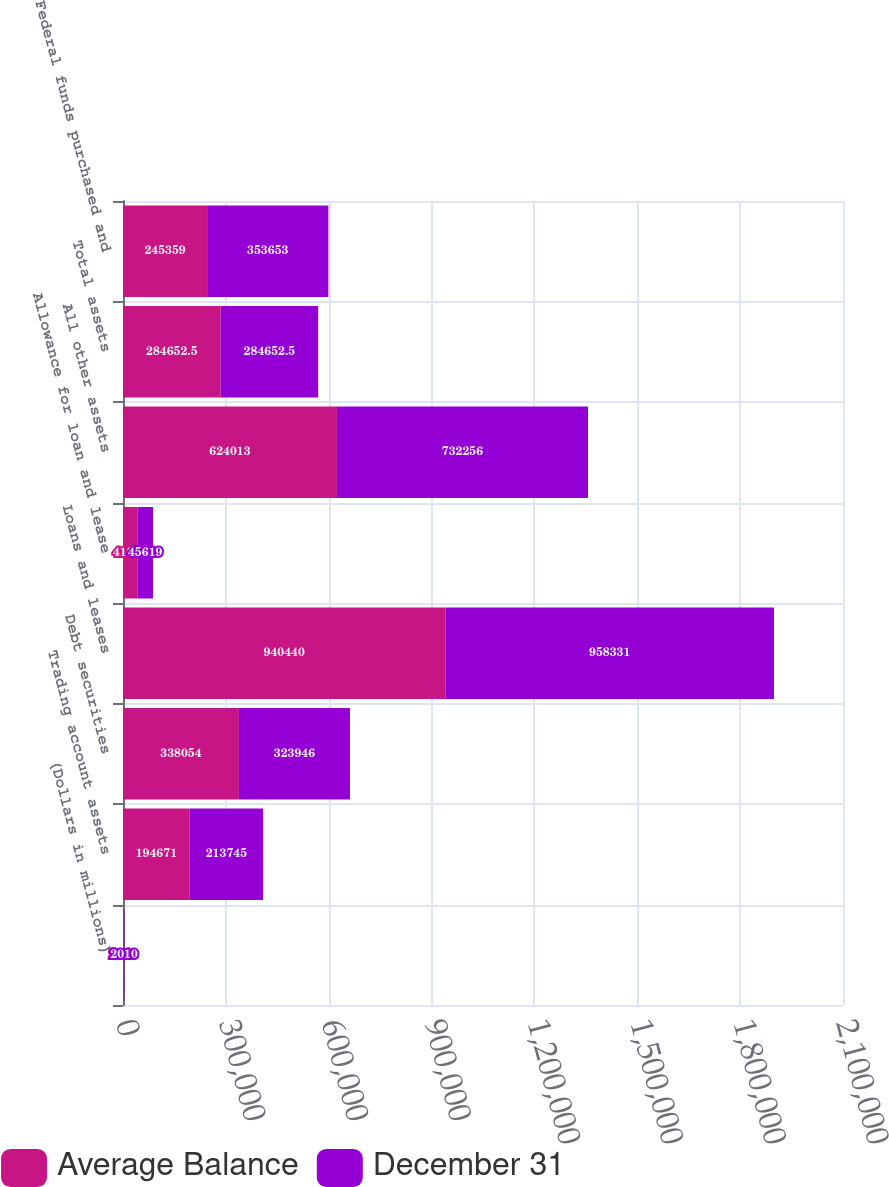<chart> <loc_0><loc_0><loc_500><loc_500><stacked_bar_chart><ecel><fcel>(Dollars in millions)<fcel>Trading account assets<fcel>Debt securities<fcel>Loans and leases<fcel>Allowance for loan and lease<fcel>All other assets<fcel>Total assets<fcel>Federal funds purchased and<nl><fcel>Average Balance<fcel>2010<fcel>194671<fcel>338054<fcel>940440<fcel>41885<fcel>624013<fcel>284652<fcel>245359<nl><fcel>December 31<fcel>2010<fcel>213745<fcel>323946<fcel>958331<fcel>45619<fcel>732256<fcel>284652<fcel>353653<nl></chart> 